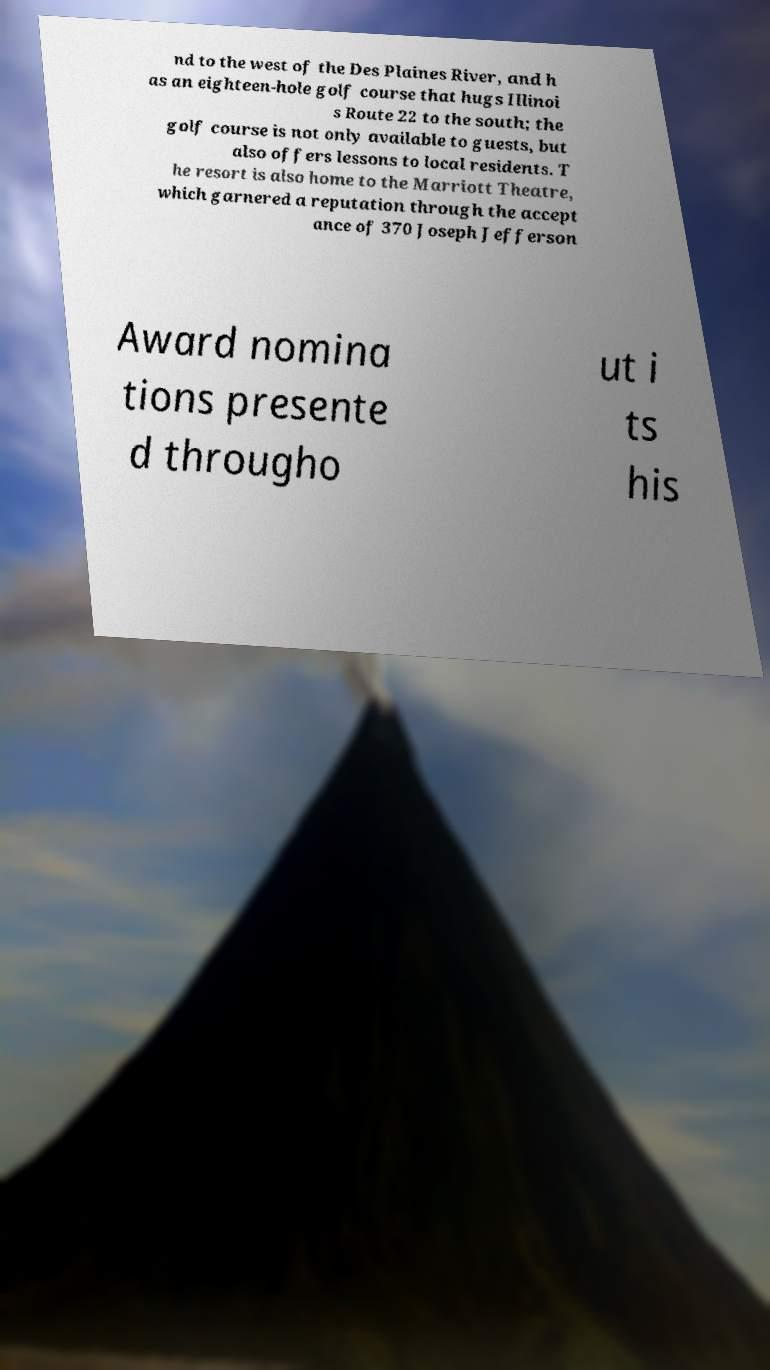For documentation purposes, I need the text within this image transcribed. Could you provide that? nd to the west of the Des Plaines River, and h as an eighteen-hole golf course that hugs Illinoi s Route 22 to the south; the golf course is not only available to guests, but also offers lessons to local residents. T he resort is also home to the Marriott Theatre, which garnered a reputation through the accept ance of 370 Joseph Jefferson Award nomina tions presente d througho ut i ts his 